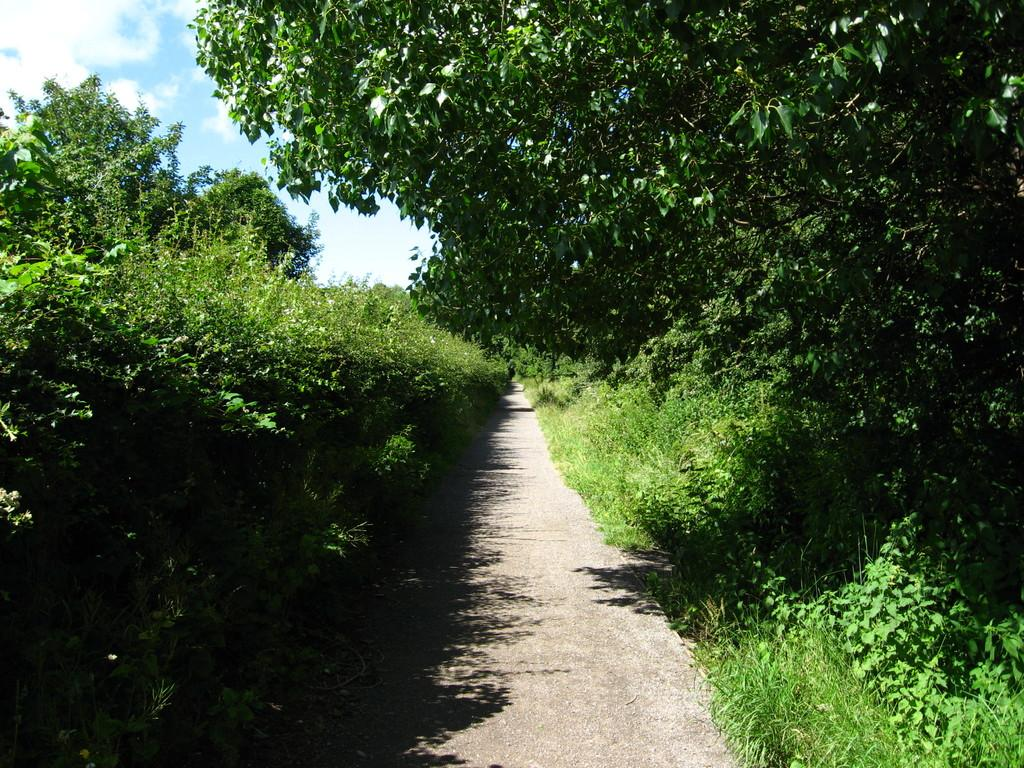What is the main feature in the center of the image? There is a path in the center of the image. What can be seen in the background of the image? There are plants, trees, and the sky visible in the background of the image. What type of liquid can be seen flowing along the path in the image? There is no liquid visible in the image; it is a path surrounded by plants, trees, and the sky. 